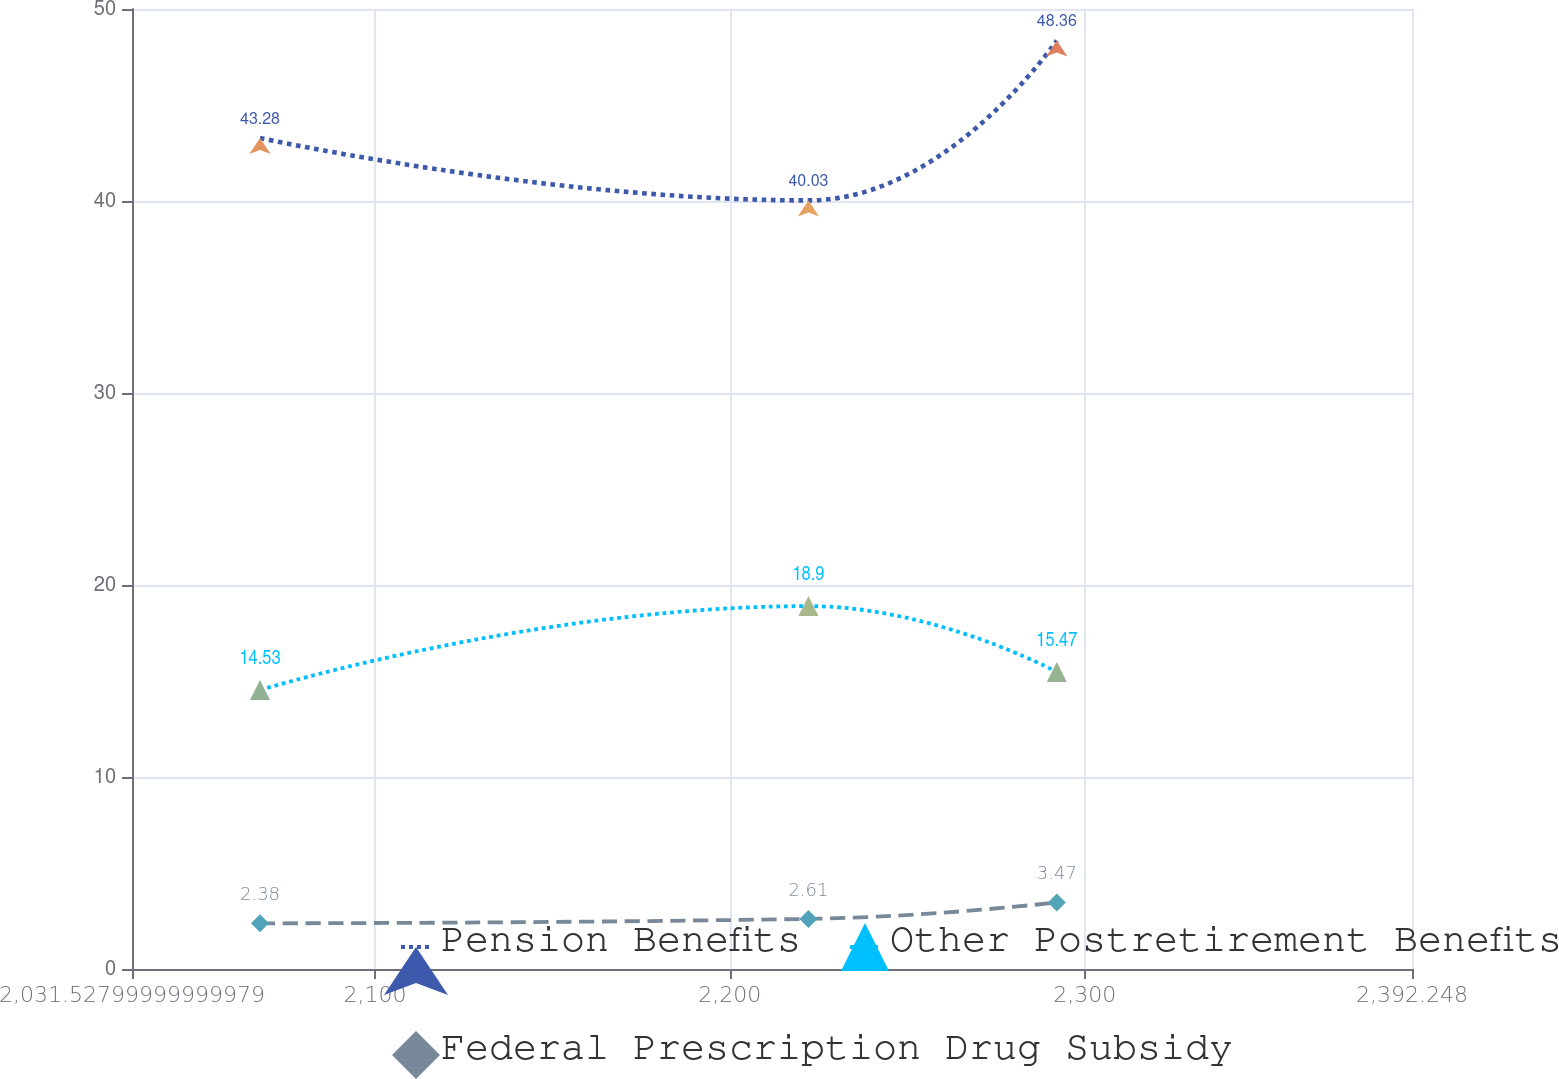Convert chart to OTSL. <chart><loc_0><loc_0><loc_500><loc_500><line_chart><ecel><fcel>Pension Benefits<fcel>Other Postretirement Benefits<fcel>Federal Prescription Drug Subsidy<nl><fcel>2067.6<fcel>43.28<fcel>14.53<fcel>2.38<nl><fcel>2222.16<fcel>40.03<fcel>18.9<fcel>2.61<nl><fcel>2292.15<fcel>48.36<fcel>15.47<fcel>3.47<nl><fcel>2394.01<fcel>59.94<fcel>20.89<fcel>3.59<nl><fcel>2428.32<fcel>57.8<fcel>21.58<fcel>3.71<nl></chart> 